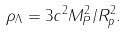<formula> <loc_0><loc_0><loc_500><loc_500>\rho _ { \Lambda } = 3 c ^ { 2 } M ^ { 2 } _ { P } / R ^ { 2 } _ { p } .</formula> 